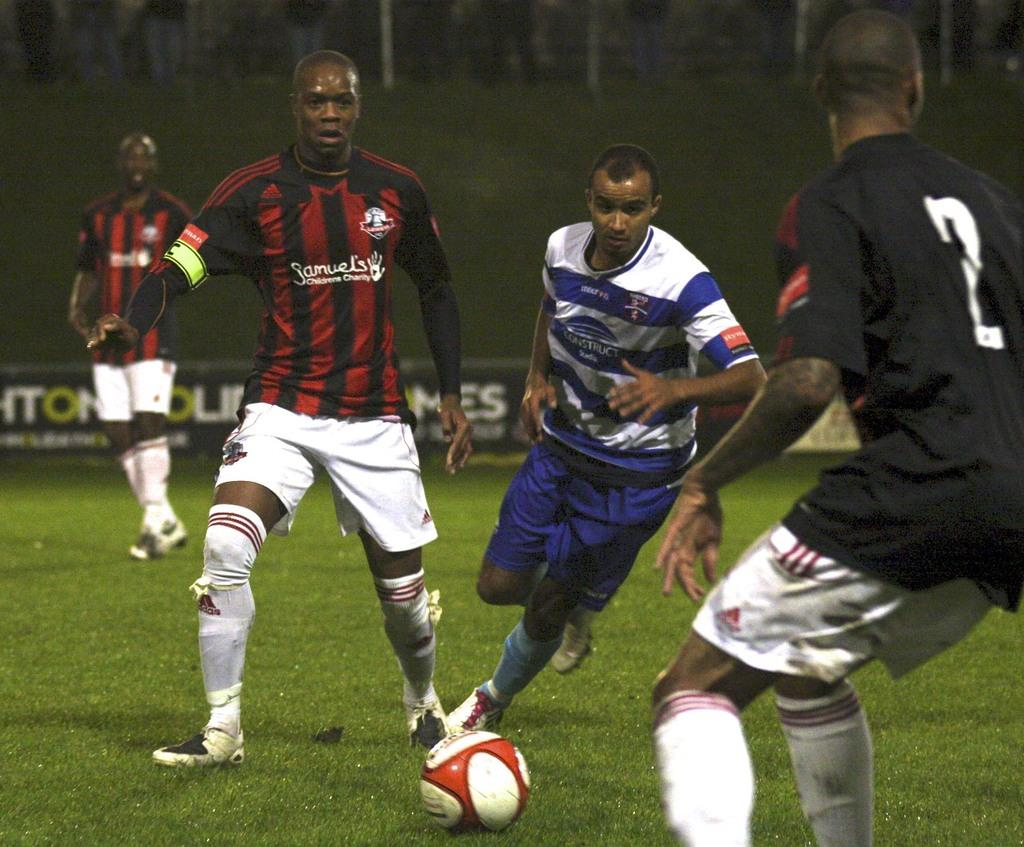What activity are the people in the image engaged in? The people in the image are playing football. Where are the people playing football located in the image? The people are in the center of the image. What type of surface are they playing on? There is grass at the bottom of the image, which suggests they are playing on a grassy field. Can you see a ray of light shining on the football in the image? There is no mention of a ray of light in the provided facts, so we cannot determine if one is present in the image. 